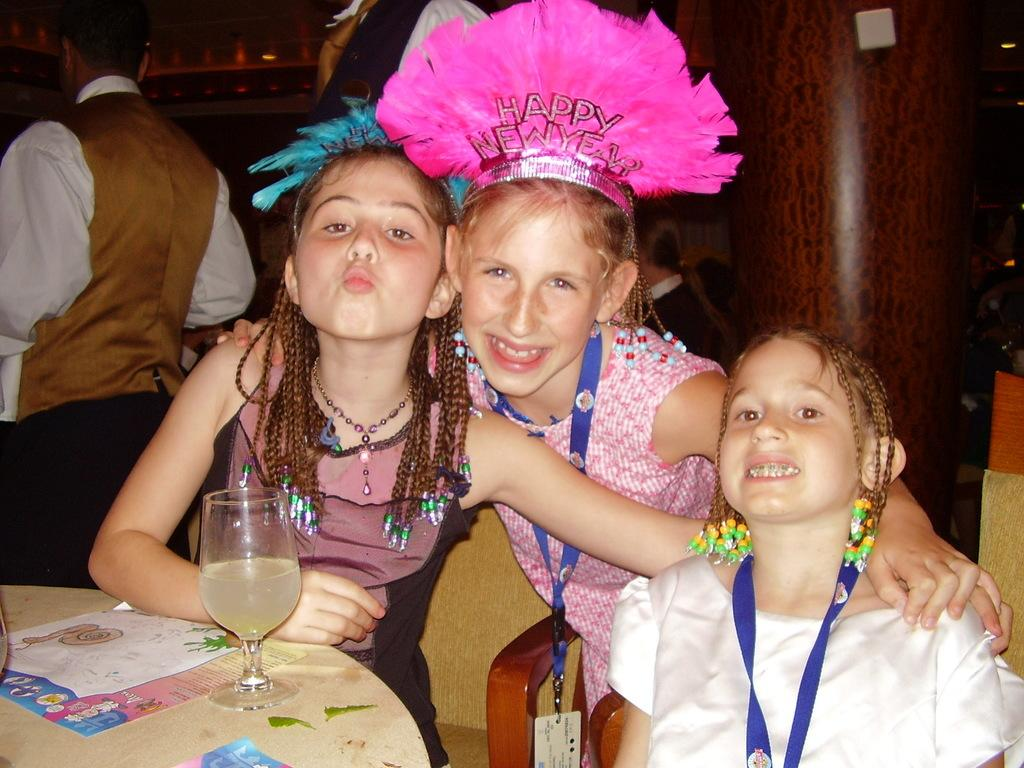What are the people in the image wearing? The people in the image are wearing clothes. Where is the table located in the image? The table is in the bottom left of the image. What objects can be seen on the table? A glass and a paper are present on the table. What architectural feature is on the right side of the image? There is a pillar on the right side of the image. Can you describe the cabbage that is being twisted by the people in the image? There is no cabbage present in the image, nor is anyone twisting anything. 